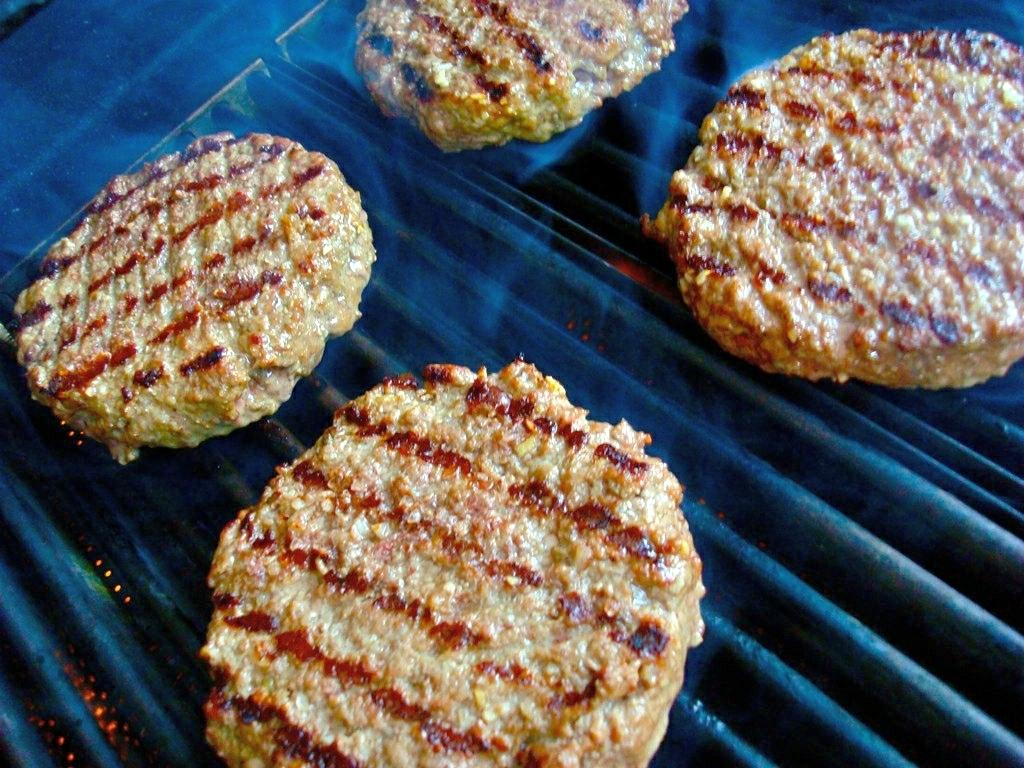What type of food items can be seen in the image? The image contains food items, but the specific types cannot be determined from the provided facts. What is located at the bottom of the image? There is a grill at the bottom of the image. Can you tell me how many kitties are playing with a gun in the image? There are no kitties or guns present in the image. 